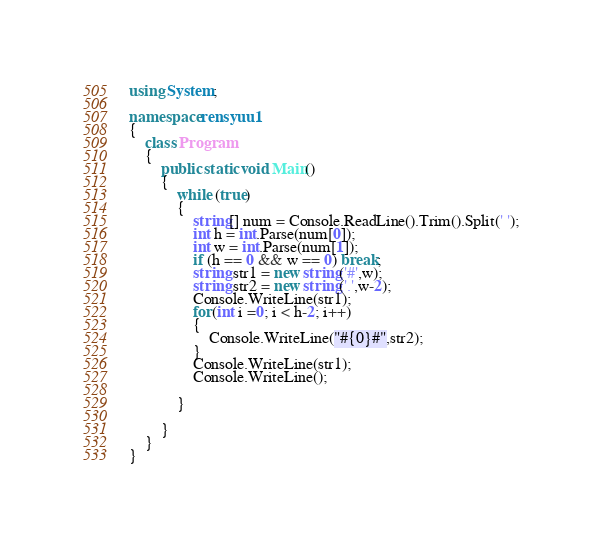<code> <loc_0><loc_0><loc_500><loc_500><_C#_>using System;

namespace rensyuu1
{
    class Program
    {
        public static void Main()
        {
            while (true)
            {
                string[] num = Console.ReadLine().Trim().Split(' ');
                int h = int.Parse(num[0]);
                int w = int.Parse(num[1]);
                if (h == 0 && w == 0) break;
                string str1 = new string('#',w);
                string str2 = new string('.',w-2);
                Console.WriteLine(str1);
                for(int i =0; i < h-2; i++)
                {
                    Console.WriteLine("#{0}#",str2);
                }
                Console.WriteLine(str1);
                Console.WriteLine();

            }

        }
    }
}
</code> 